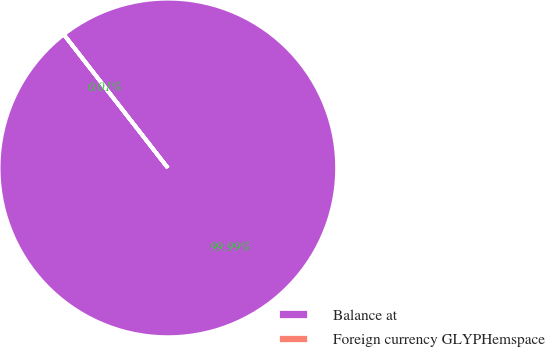<chart> <loc_0><loc_0><loc_500><loc_500><pie_chart><fcel>Balance at<fcel>Foreign currency GLYPHemspace<nl><fcel>99.99%<fcel>0.01%<nl></chart> 